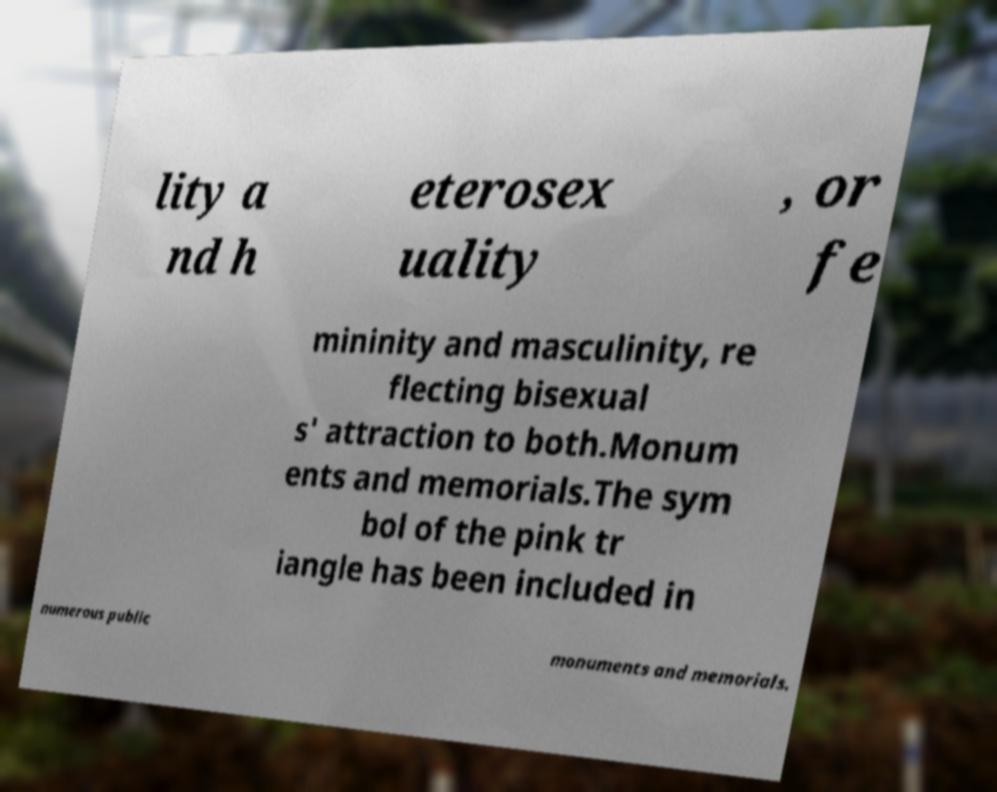Could you assist in decoding the text presented in this image and type it out clearly? lity a nd h eterosex uality , or fe mininity and masculinity, re flecting bisexual s' attraction to both.Monum ents and memorials.The sym bol of the pink tr iangle has been included in numerous public monuments and memorials. 